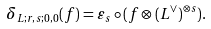Convert formula to latex. <formula><loc_0><loc_0><loc_500><loc_500>\delta _ { L ; r , s ; 0 , 0 } ( f ) = \varepsilon _ { s } \circ ( f \otimes ( L ^ { \vee } ) ^ { \otimes s } ) .</formula> 